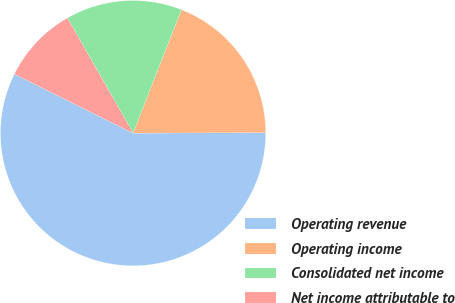Convert chart to OTSL. <chart><loc_0><loc_0><loc_500><loc_500><pie_chart><fcel>Operating revenue<fcel>Operating income<fcel>Consolidated net income<fcel>Net income attributable to<nl><fcel>57.41%<fcel>19.0%<fcel>14.2%<fcel>9.4%<nl></chart> 